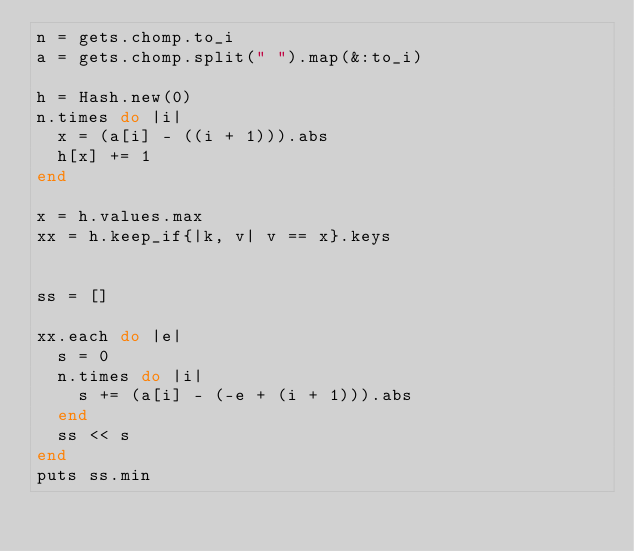Convert code to text. <code><loc_0><loc_0><loc_500><loc_500><_Ruby_>n = gets.chomp.to_i
a = gets.chomp.split(" ").map(&:to_i)

h = Hash.new(0)
n.times do |i|
  x = (a[i] - ((i + 1))).abs
  h[x] += 1
end

x = h.values.max
xx = h.keep_if{|k, v| v == x}.keys


ss = []

xx.each do |e|
  s = 0
  n.times do |i|
    s += (a[i] - (-e + (i + 1))).abs
  end
  ss << s
end
puts ss.min</code> 